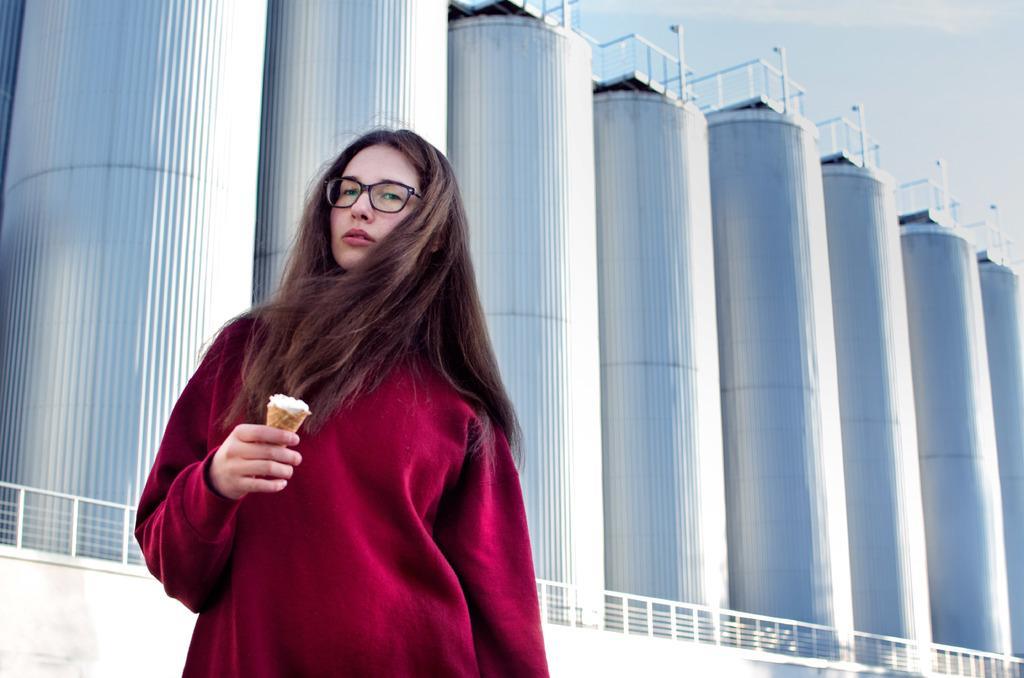Please provide a concise description of this image. In this image we can see the person standing and holding food item. At the back there is the wall with fence and there are machines, poles and the sky. 